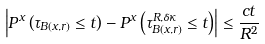Convert formula to latex. <formula><loc_0><loc_0><loc_500><loc_500>\left | P ^ { x } \left ( \tau _ { B ( x , r ) } \leq t \right ) - P ^ { x } \left ( \tau ^ { R , \delta \kappa } _ { B ( x , r ) } \leq t \right ) \right | \leq \frac { c t } { R ^ { 2 } }</formula> 